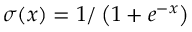Convert formula to latex. <formula><loc_0><loc_0><loc_500><loc_500>\sigma ( x ) = 1 / \left ( 1 + e ^ { - x } \right )</formula> 